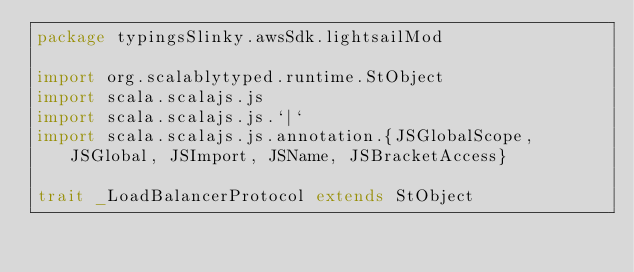Convert code to text. <code><loc_0><loc_0><loc_500><loc_500><_Scala_>package typingsSlinky.awsSdk.lightsailMod

import org.scalablytyped.runtime.StObject
import scala.scalajs.js
import scala.scalajs.js.`|`
import scala.scalajs.js.annotation.{JSGlobalScope, JSGlobal, JSImport, JSName, JSBracketAccess}

trait _LoadBalancerProtocol extends StObject
</code> 